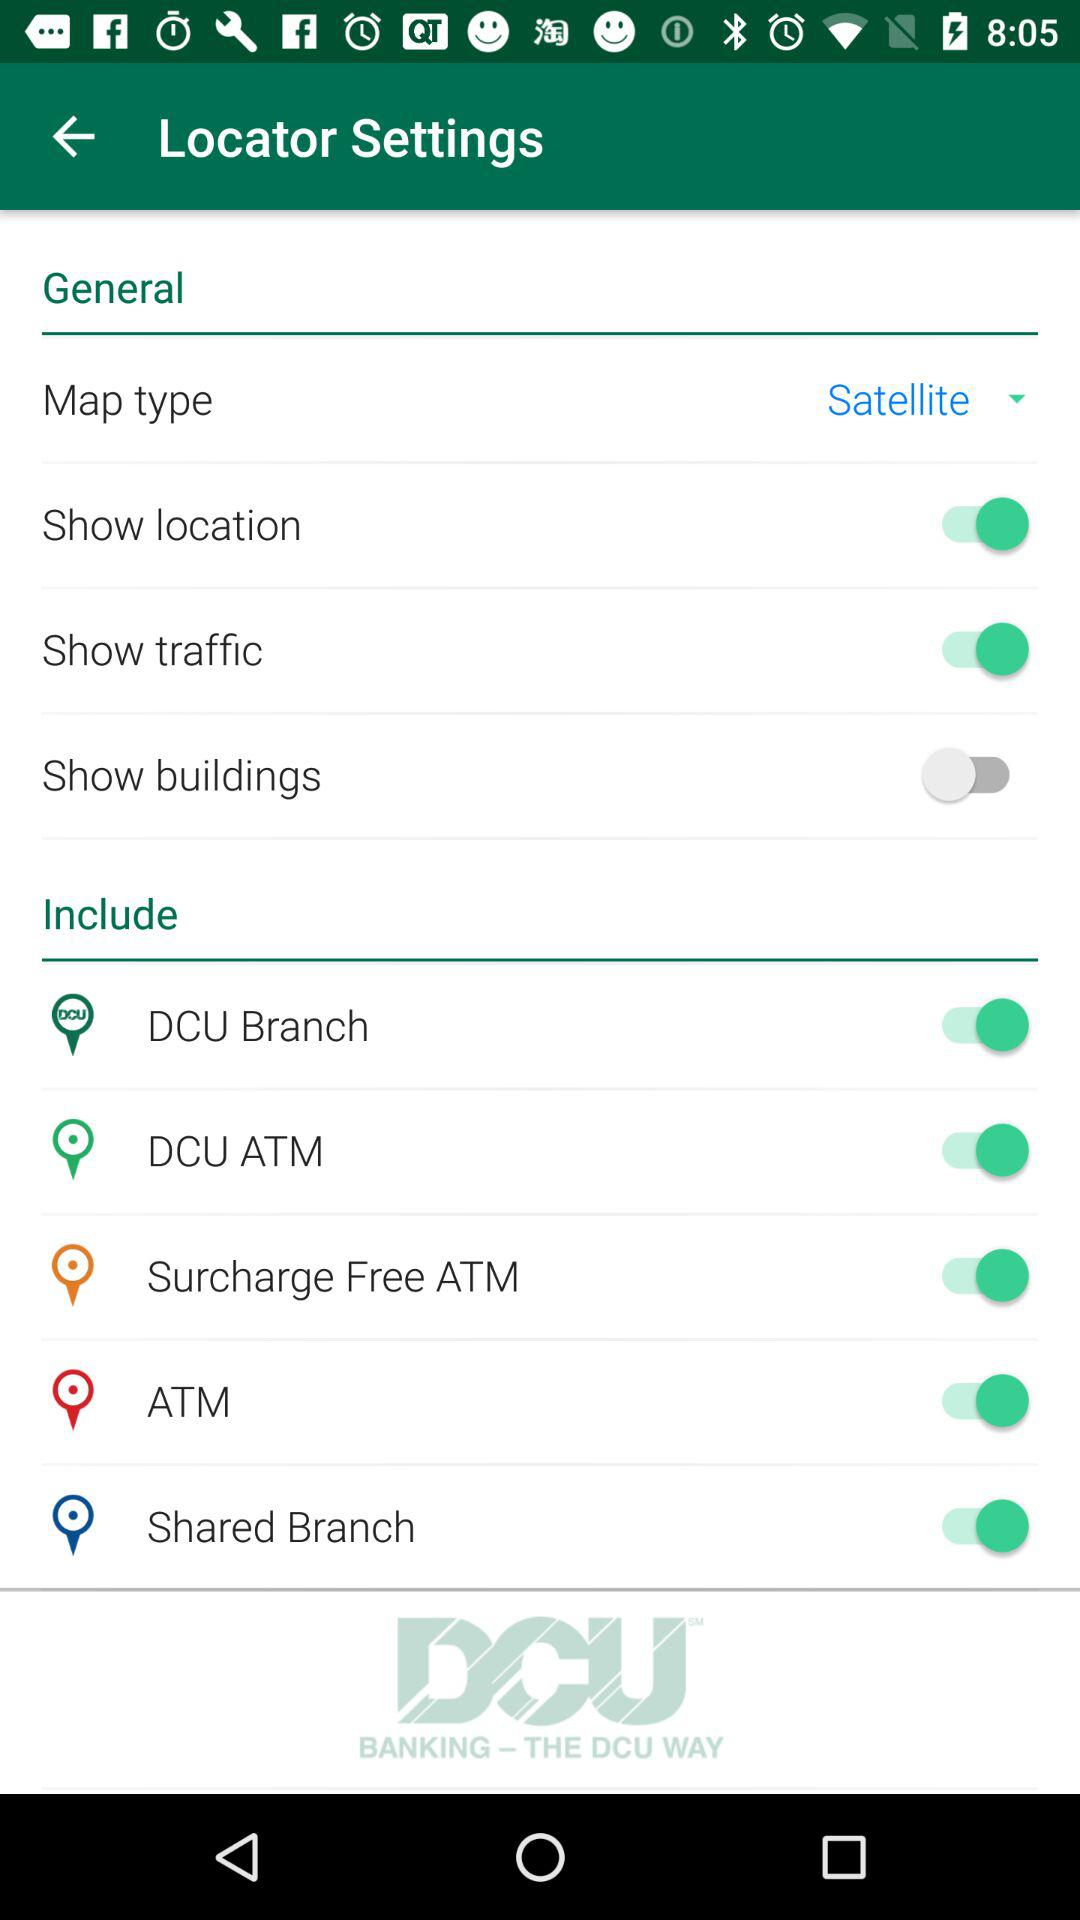What is the status of the location and traffic settings? The status of both location and traffic settings are on. 